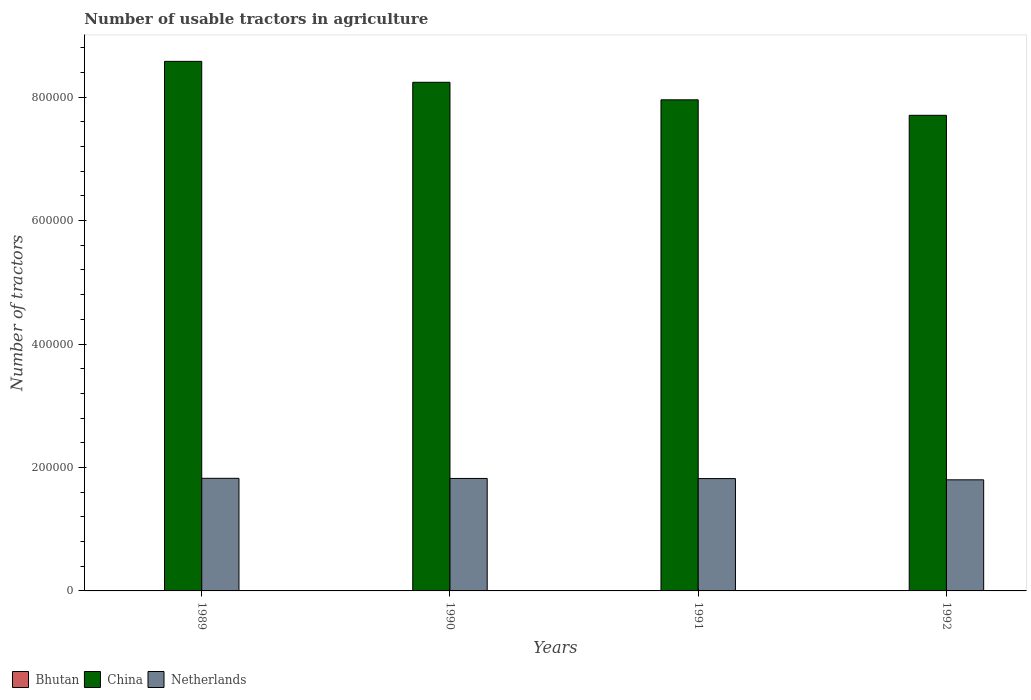How many groups of bars are there?
Give a very brief answer. 4. Are the number of bars on each tick of the X-axis equal?
Your answer should be very brief. Yes. How many bars are there on the 1st tick from the right?
Provide a short and direct response. 3. What is the number of usable tractors in agriculture in China in 1992?
Make the answer very short. 7.71e+05. In which year was the number of usable tractors in agriculture in Bhutan minimum?
Give a very brief answer. 1989. What is the total number of usable tractors in agriculture in China in the graph?
Offer a terse response. 3.25e+06. What is the difference between the number of usable tractors in agriculture in Netherlands in 1990 and that in 1992?
Make the answer very short. 2228. What is the difference between the number of usable tractors in agriculture in Netherlands in 1992 and the number of usable tractors in agriculture in China in 1991?
Your answer should be very brief. -6.16e+05. In the year 1992, what is the difference between the number of usable tractors in agriculture in Netherlands and number of usable tractors in agriculture in Bhutan?
Make the answer very short. 1.80e+05. What is the ratio of the number of usable tractors in agriculture in Bhutan in 1991 to that in 1992?
Provide a succinct answer. 0.86. What is the difference between the highest and the second highest number of usable tractors in agriculture in Netherlands?
Offer a very short reply. 222. What is the difference between the highest and the lowest number of usable tractors in agriculture in Bhutan?
Your answer should be compact. 30. In how many years, is the number of usable tractors in agriculture in Netherlands greater than the average number of usable tractors in agriculture in Netherlands taken over all years?
Make the answer very short. 3. Is the sum of the number of usable tractors in agriculture in Netherlands in 1989 and 1990 greater than the maximum number of usable tractors in agriculture in Bhutan across all years?
Your answer should be compact. Yes. What does the 1st bar from the left in 1991 represents?
Your answer should be compact. Bhutan. What does the 3rd bar from the right in 1989 represents?
Give a very brief answer. Bhutan. Is it the case that in every year, the sum of the number of usable tractors in agriculture in Bhutan and number of usable tractors in agriculture in Netherlands is greater than the number of usable tractors in agriculture in China?
Give a very brief answer. No. How many bars are there?
Your answer should be very brief. 12. How many years are there in the graph?
Make the answer very short. 4. What is the difference between two consecutive major ticks on the Y-axis?
Your answer should be compact. 2.00e+05. Are the values on the major ticks of Y-axis written in scientific E-notation?
Provide a short and direct response. No. Does the graph contain grids?
Make the answer very short. No. How many legend labels are there?
Your response must be concise. 3. How are the legend labels stacked?
Provide a short and direct response. Horizontal. What is the title of the graph?
Provide a succinct answer. Number of usable tractors in agriculture. What is the label or title of the X-axis?
Your answer should be compact. Years. What is the label or title of the Y-axis?
Your answer should be very brief. Number of tractors. What is the Number of tractors in Bhutan in 1989?
Your answer should be very brief. 40. What is the Number of tractors of China in 1989?
Provide a succinct answer. 8.58e+05. What is the Number of tractors of Netherlands in 1989?
Your answer should be very brief. 1.82e+05. What is the Number of tractors in China in 1990?
Offer a terse response. 8.24e+05. What is the Number of tractors of Netherlands in 1990?
Provide a short and direct response. 1.82e+05. What is the Number of tractors in Bhutan in 1991?
Your answer should be compact. 60. What is the Number of tractors of China in 1991?
Give a very brief answer. 7.96e+05. What is the Number of tractors of Netherlands in 1991?
Give a very brief answer. 1.82e+05. What is the Number of tractors of China in 1992?
Your response must be concise. 7.71e+05. What is the Number of tractors of Netherlands in 1992?
Your answer should be very brief. 1.80e+05. Across all years, what is the maximum Number of tractors in China?
Ensure brevity in your answer.  8.58e+05. Across all years, what is the maximum Number of tractors in Netherlands?
Offer a very short reply. 1.82e+05. Across all years, what is the minimum Number of tractors of China?
Offer a very short reply. 7.71e+05. What is the total Number of tractors of Bhutan in the graph?
Your answer should be very brief. 220. What is the total Number of tractors in China in the graph?
Offer a terse response. 3.25e+06. What is the total Number of tractors in Netherlands in the graph?
Your answer should be very brief. 7.27e+05. What is the difference between the Number of tractors in China in 1989 and that in 1990?
Ensure brevity in your answer.  3.39e+04. What is the difference between the Number of tractors of Netherlands in 1989 and that in 1990?
Offer a terse response. 222. What is the difference between the Number of tractors of Bhutan in 1989 and that in 1991?
Provide a short and direct response. -20. What is the difference between the Number of tractors of China in 1989 and that in 1991?
Provide a short and direct response. 6.23e+04. What is the difference between the Number of tractors in Netherlands in 1989 and that in 1991?
Provide a short and direct response. 450. What is the difference between the Number of tractors of Bhutan in 1989 and that in 1992?
Keep it short and to the point. -30. What is the difference between the Number of tractors in China in 1989 and that in 1992?
Your answer should be very brief. 8.74e+04. What is the difference between the Number of tractors of Netherlands in 1989 and that in 1992?
Keep it short and to the point. 2450. What is the difference between the Number of tractors of China in 1990 and that in 1991?
Provide a short and direct response. 2.84e+04. What is the difference between the Number of tractors of Netherlands in 1990 and that in 1991?
Give a very brief answer. 228. What is the difference between the Number of tractors of Bhutan in 1990 and that in 1992?
Your answer should be compact. -20. What is the difference between the Number of tractors of China in 1990 and that in 1992?
Your answer should be very brief. 5.35e+04. What is the difference between the Number of tractors in Netherlands in 1990 and that in 1992?
Your answer should be compact. 2228. What is the difference between the Number of tractors in Bhutan in 1991 and that in 1992?
Provide a succinct answer. -10. What is the difference between the Number of tractors of China in 1991 and that in 1992?
Offer a very short reply. 2.51e+04. What is the difference between the Number of tractors in Bhutan in 1989 and the Number of tractors in China in 1990?
Make the answer very short. -8.24e+05. What is the difference between the Number of tractors of Bhutan in 1989 and the Number of tractors of Netherlands in 1990?
Provide a short and direct response. -1.82e+05. What is the difference between the Number of tractors of China in 1989 and the Number of tractors of Netherlands in 1990?
Give a very brief answer. 6.76e+05. What is the difference between the Number of tractors in Bhutan in 1989 and the Number of tractors in China in 1991?
Ensure brevity in your answer.  -7.96e+05. What is the difference between the Number of tractors of Bhutan in 1989 and the Number of tractors of Netherlands in 1991?
Your response must be concise. -1.82e+05. What is the difference between the Number of tractors in China in 1989 and the Number of tractors in Netherlands in 1991?
Offer a very short reply. 6.76e+05. What is the difference between the Number of tractors of Bhutan in 1989 and the Number of tractors of China in 1992?
Keep it short and to the point. -7.71e+05. What is the difference between the Number of tractors of Bhutan in 1989 and the Number of tractors of Netherlands in 1992?
Keep it short and to the point. -1.80e+05. What is the difference between the Number of tractors in China in 1989 and the Number of tractors in Netherlands in 1992?
Your answer should be very brief. 6.78e+05. What is the difference between the Number of tractors of Bhutan in 1990 and the Number of tractors of China in 1991?
Offer a very short reply. -7.96e+05. What is the difference between the Number of tractors of Bhutan in 1990 and the Number of tractors of Netherlands in 1991?
Offer a terse response. -1.82e+05. What is the difference between the Number of tractors of China in 1990 and the Number of tractors of Netherlands in 1991?
Your answer should be very brief. 6.42e+05. What is the difference between the Number of tractors in Bhutan in 1990 and the Number of tractors in China in 1992?
Your answer should be compact. -7.71e+05. What is the difference between the Number of tractors in Bhutan in 1990 and the Number of tractors in Netherlands in 1992?
Provide a succinct answer. -1.80e+05. What is the difference between the Number of tractors of China in 1990 and the Number of tractors of Netherlands in 1992?
Make the answer very short. 6.44e+05. What is the difference between the Number of tractors in Bhutan in 1991 and the Number of tractors in China in 1992?
Provide a short and direct response. -7.71e+05. What is the difference between the Number of tractors in Bhutan in 1991 and the Number of tractors in Netherlands in 1992?
Make the answer very short. -1.80e+05. What is the difference between the Number of tractors of China in 1991 and the Number of tractors of Netherlands in 1992?
Provide a succinct answer. 6.16e+05. What is the average Number of tractors of China per year?
Your answer should be compact. 8.12e+05. What is the average Number of tractors in Netherlands per year?
Ensure brevity in your answer.  1.82e+05. In the year 1989, what is the difference between the Number of tractors in Bhutan and Number of tractors in China?
Your answer should be very brief. -8.58e+05. In the year 1989, what is the difference between the Number of tractors of Bhutan and Number of tractors of Netherlands?
Keep it short and to the point. -1.82e+05. In the year 1989, what is the difference between the Number of tractors of China and Number of tractors of Netherlands?
Give a very brief answer. 6.76e+05. In the year 1990, what is the difference between the Number of tractors in Bhutan and Number of tractors in China?
Provide a short and direct response. -8.24e+05. In the year 1990, what is the difference between the Number of tractors in Bhutan and Number of tractors in Netherlands?
Your answer should be very brief. -1.82e+05. In the year 1990, what is the difference between the Number of tractors of China and Number of tractors of Netherlands?
Your answer should be very brief. 6.42e+05. In the year 1991, what is the difference between the Number of tractors of Bhutan and Number of tractors of China?
Your response must be concise. -7.96e+05. In the year 1991, what is the difference between the Number of tractors of Bhutan and Number of tractors of Netherlands?
Give a very brief answer. -1.82e+05. In the year 1991, what is the difference between the Number of tractors of China and Number of tractors of Netherlands?
Your answer should be very brief. 6.14e+05. In the year 1992, what is the difference between the Number of tractors in Bhutan and Number of tractors in China?
Keep it short and to the point. -7.71e+05. In the year 1992, what is the difference between the Number of tractors of Bhutan and Number of tractors of Netherlands?
Make the answer very short. -1.80e+05. In the year 1992, what is the difference between the Number of tractors in China and Number of tractors in Netherlands?
Offer a very short reply. 5.91e+05. What is the ratio of the Number of tractors of Bhutan in 1989 to that in 1990?
Your response must be concise. 0.8. What is the ratio of the Number of tractors in China in 1989 to that in 1990?
Ensure brevity in your answer.  1.04. What is the ratio of the Number of tractors in Netherlands in 1989 to that in 1990?
Your response must be concise. 1. What is the ratio of the Number of tractors in China in 1989 to that in 1991?
Give a very brief answer. 1.08. What is the ratio of the Number of tractors in China in 1989 to that in 1992?
Give a very brief answer. 1.11. What is the ratio of the Number of tractors in Netherlands in 1989 to that in 1992?
Provide a short and direct response. 1.01. What is the ratio of the Number of tractors in Bhutan in 1990 to that in 1991?
Offer a very short reply. 0.83. What is the ratio of the Number of tractors in China in 1990 to that in 1991?
Your answer should be very brief. 1.04. What is the ratio of the Number of tractors in Netherlands in 1990 to that in 1991?
Offer a very short reply. 1. What is the ratio of the Number of tractors of China in 1990 to that in 1992?
Your answer should be compact. 1.07. What is the ratio of the Number of tractors of Netherlands in 1990 to that in 1992?
Your response must be concise. 1.01. What is the ratio of the Number of tractors of China in 1991 to that in 1992?
Make the answer very short. 1.03. What is the ratio of the Number of tractors of Netherlands in 1991 to that in 1992?
Keep it short and to the point. 1.01. What is the difference between the highest and the second highest Number of tractors of China?
Provide a succinct answer. 3.39e+04. What is the difference between the highest and the second highest Number of tractors in Netherlands?
Your response must be concise. 222. What is the difference between the highest and the lowest Number of tractors of China?
Your answer should be very brief. 8.74e+04. What is the difference between the highest and the lowest Number of tractors in Netherlands?
Ensure brevity in your answer.  2450. 